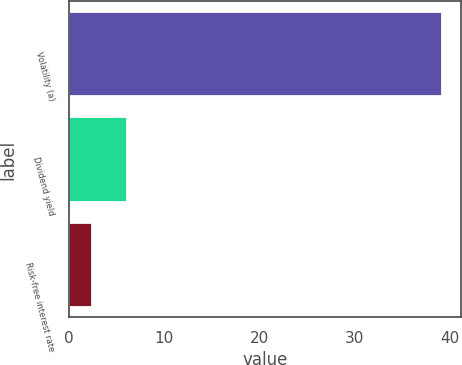<chart> <loc_0><loc_0><loc_500><loc_500><bar_chart><fcel>Volatility (a)<fcel>Dividend yield<fcel>Risk-free interest rate<nl><fcel>39.2<fcel>6.12<fcel>2.44<nl></chart> 